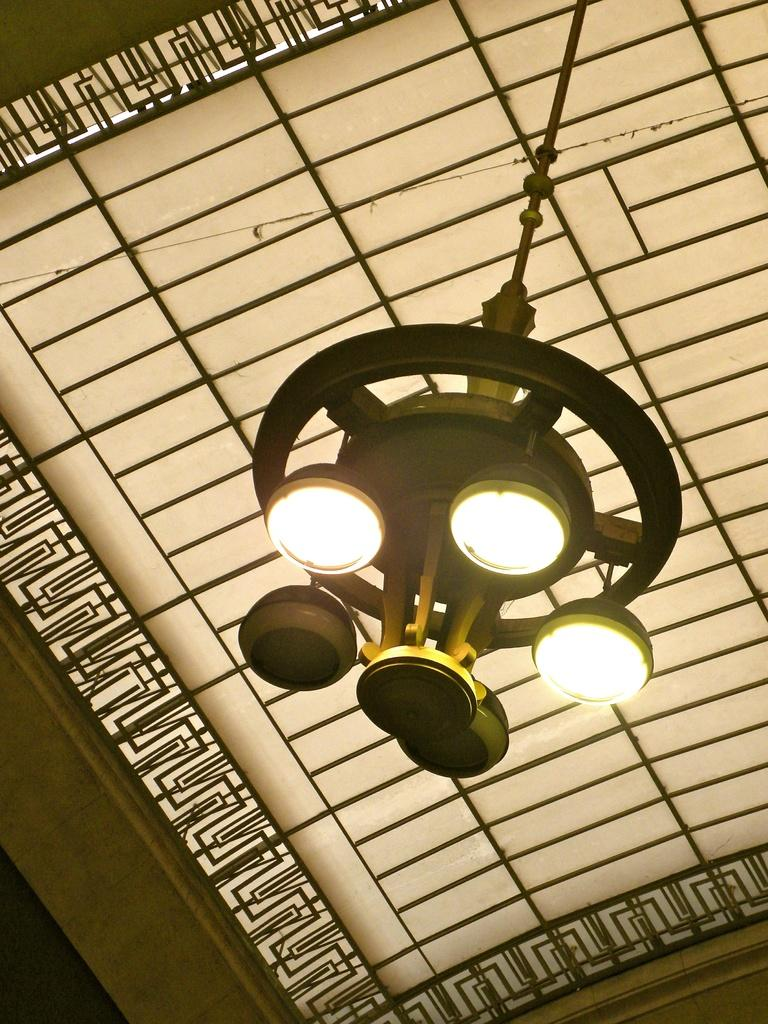What is the main object hanging from the ceiling in the image? There is a chandelier in the image. What feature of the chandelier is mentioned in the facts? The chandelier has a group of lights attached to it. Can you describe the background of the image? There is a design visible in the background of the image. What songs are being sung by the chandelier in the image? The chandelier does not sing songs in the image; it is an inanimate object. 